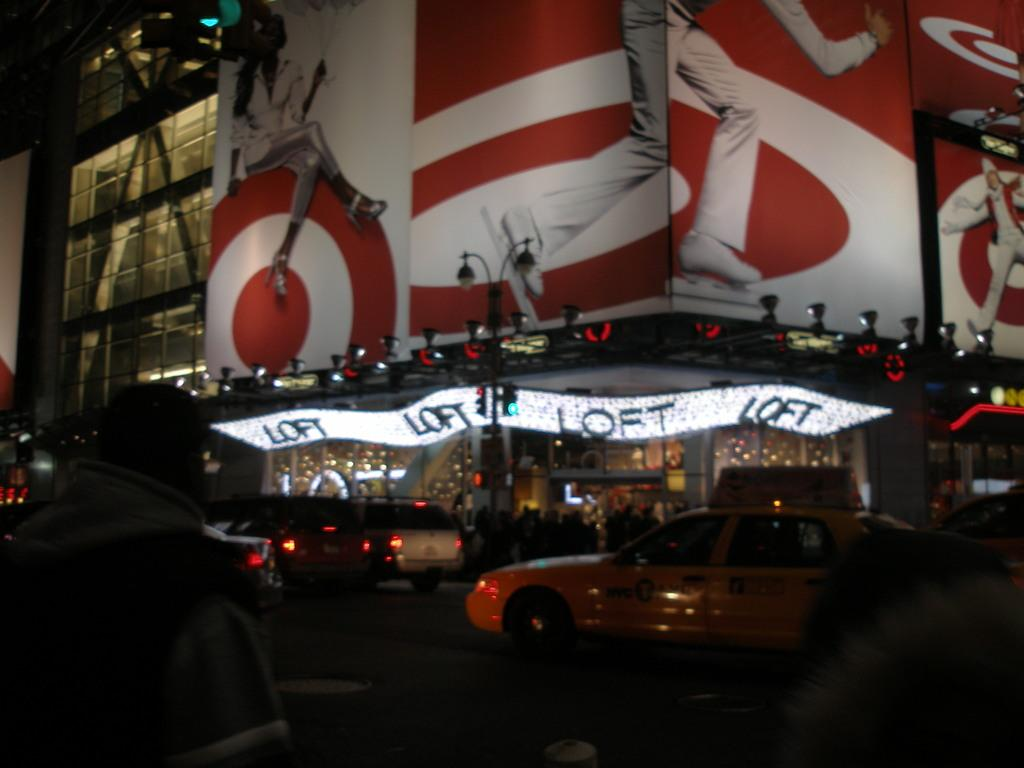<image>
Describe the image concisely. cars parked outside the Loft building in the city 